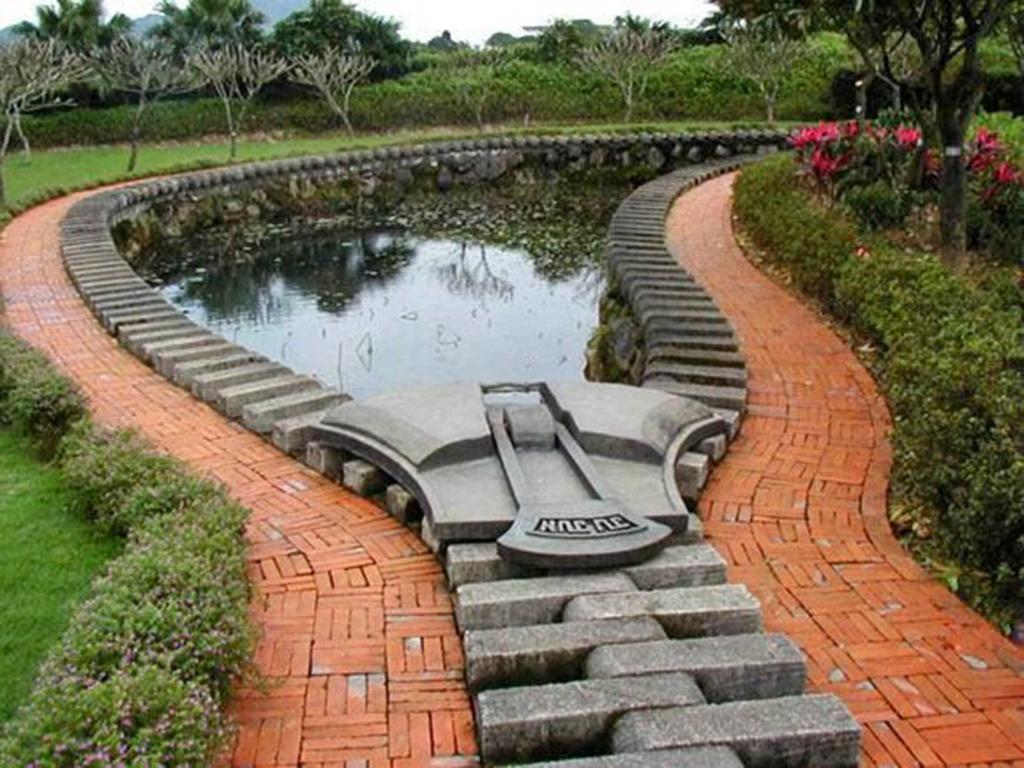How would you summarize this image in a sentence or two? In this image we can see some plants, bricks, grass, flowers, trees, mountains and water, also we can see the sky. 